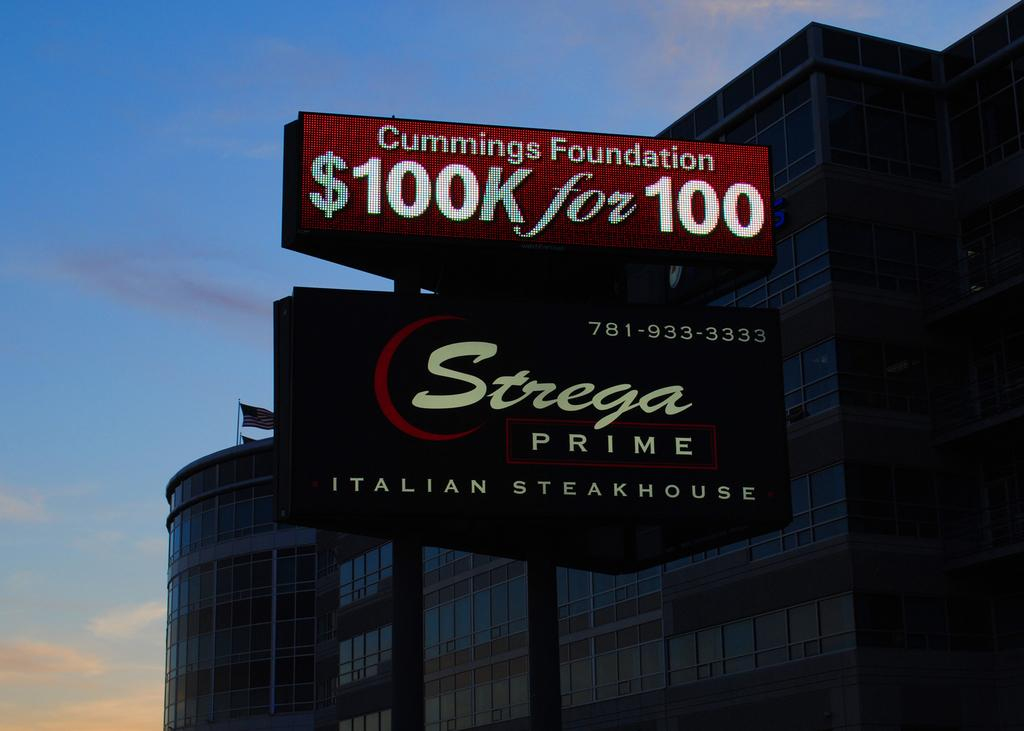<image>
Present a compact description of the photo's key features. A sign for Strega, a prime italian stakehouse 